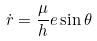Convert formula to latex. <formula><loc_0><loc_0><loc_500><loc_500>\dot { r } = \frac { \mu } { h } e \sin \theta</formula> 